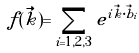Convert formula to latex. <formula><loc_0><loc_0><loc_500><loc_500>f ( \vec { k } ) = \sum _ { i = 1 , 2 , 3 } e ^ { i \vec { k } \cdot \vec { b } _ { i } }</formula> 